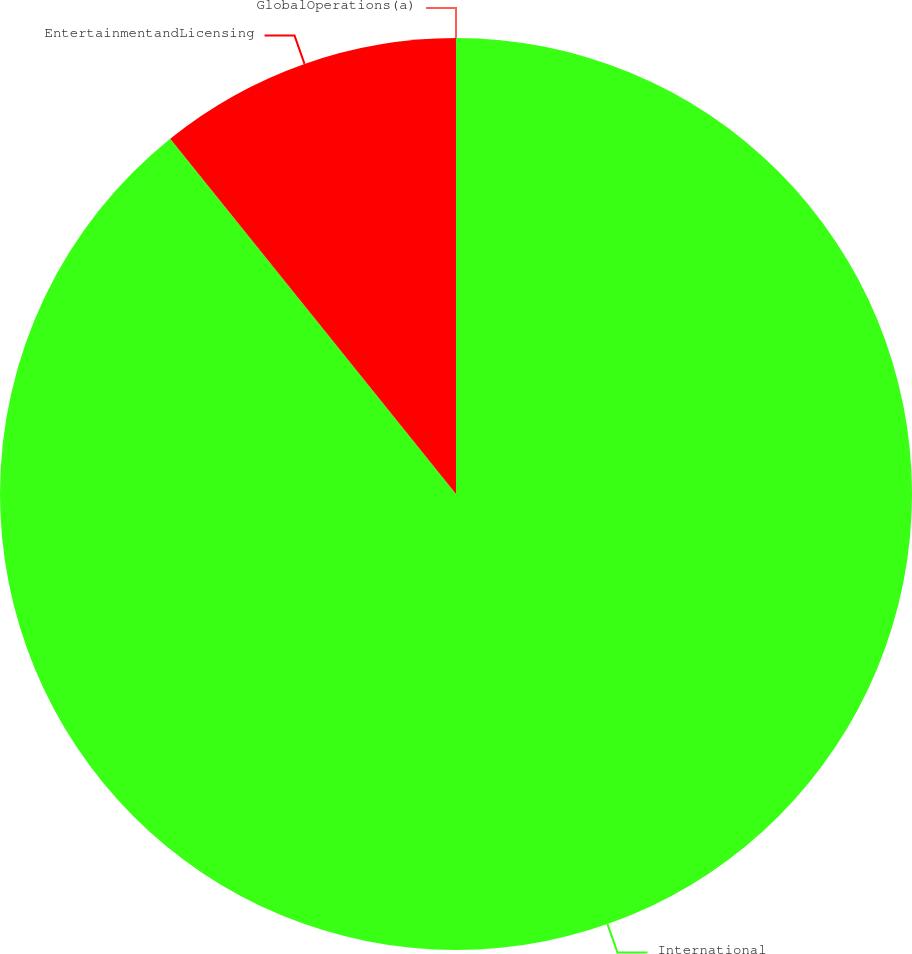<chart> <loc_0><loc_0><loc_500><loc_500><pie_chart><fcel>International<fcel>EntertainmentandLicensing<fcel>GlobalOperations(a)<nl><fcel>89.22%<fcel>10.78%<fcel>0.0%<nl></chart> 